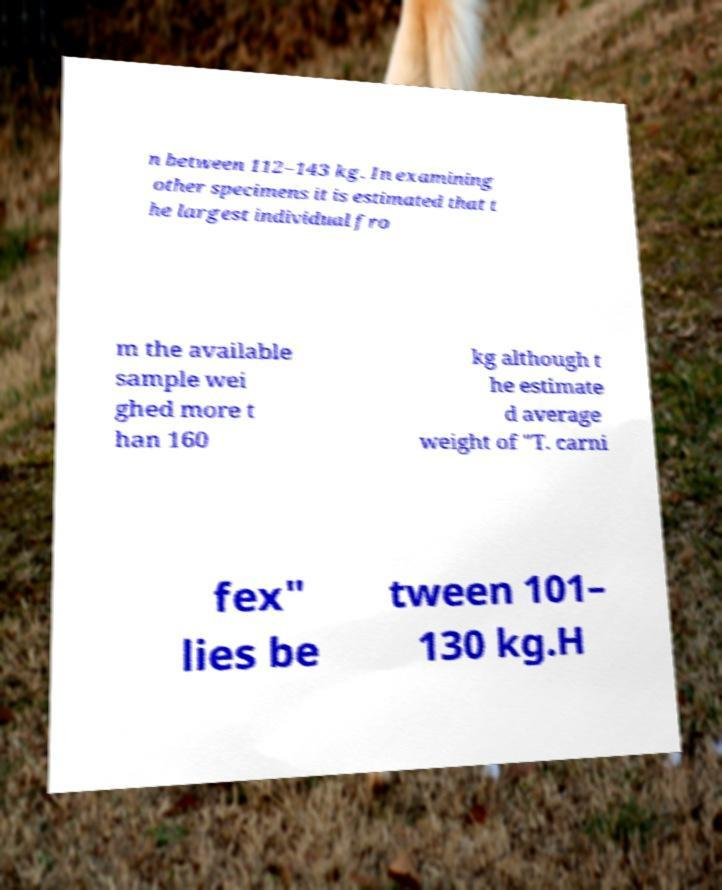Could you assist in decoding the text presented in this image and type it out clearly? n between 112–143 kg. In examining other specimens it is estimated that t he largest individual fro m the available sample wei ghed more t han 160 kg although t he estimate d average weight of "T. carni fex" lies be tween 101– 130 kg.H 